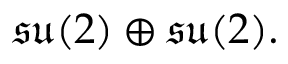Convert formula to latex. <formula><loc_0><loc_0><loc_500><loc_500>{ \mathfrak { s u } } ( 2 ) \oplus { \mathfrak { s u } } ( 2 ) .</formula> 